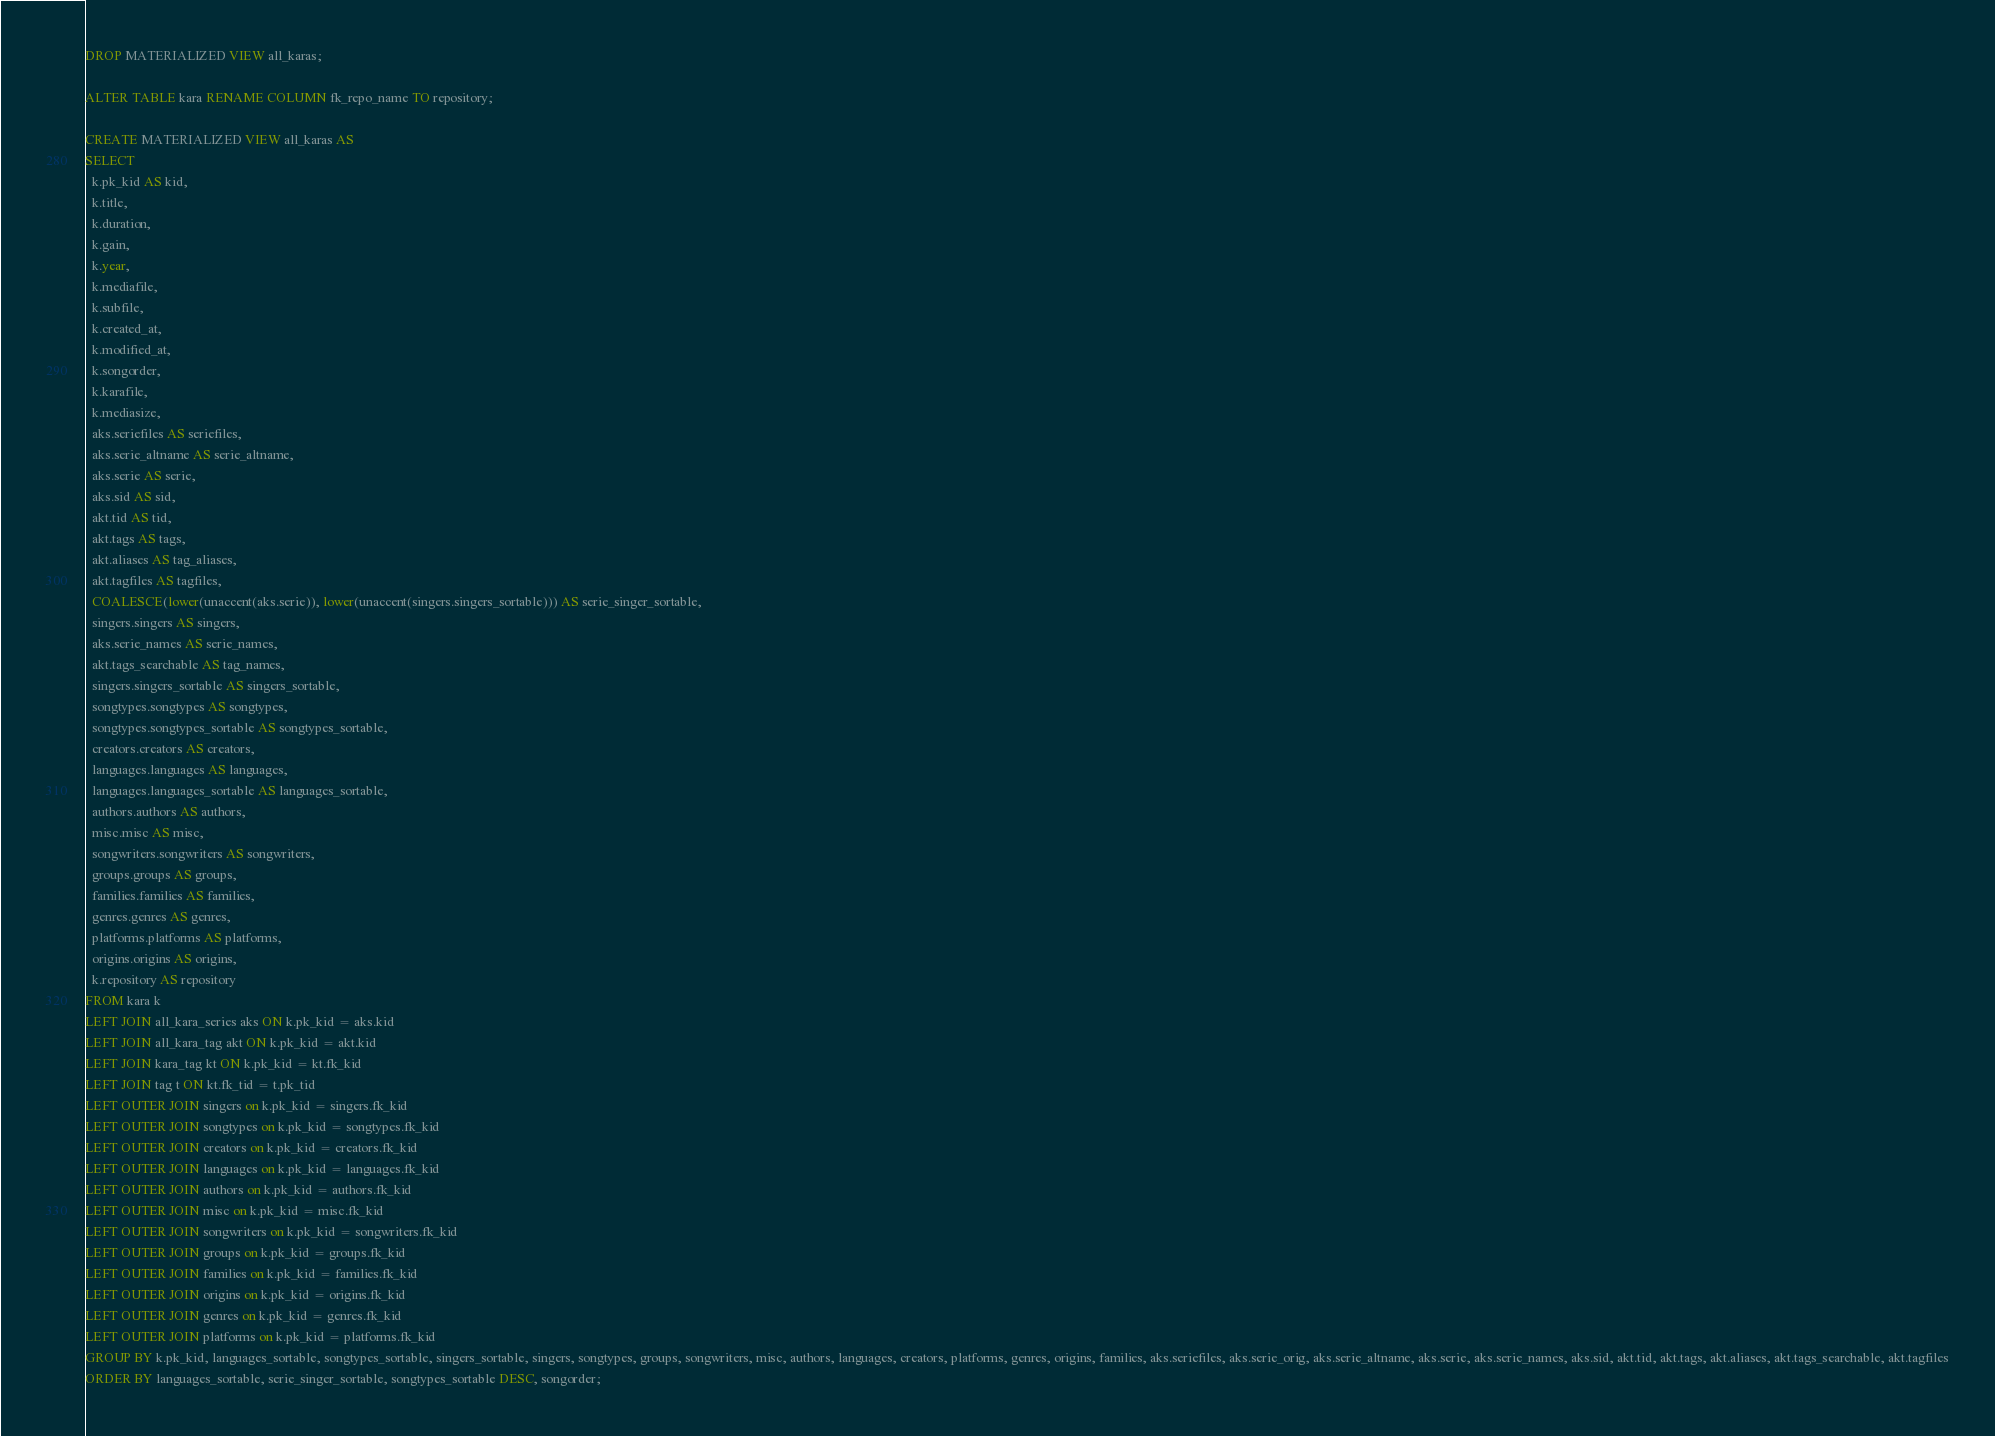Convert code to text. <code><loc_0><loc_0><loc_500><loc_500><_SQL_>
DROP MATERIALIZED VIEW all_karas;

ALTER TABLE kara RENAME COLUMN fk_repo_name TO repository;

CREATE MATERIALIZED VIEW all_karas AS
SELECT
  k.pk_kid AS kid,
  k.title,
  k.duration,
  k.gain,
  k.year,
  k.mediafile,
  k.subfile,
  k.created_at,
  k.modified_at,
  k.songorder,
  k.karafile,
  k.mediasize,
  aks.seriefiles AS seriefiles,
  aks.serie_altname AS serie_altname,
  aks.serie AS serie,
  aks.sid AS sid,
  akt.tid AS tid,
  akt.tags AS tags,
  akt.aliases AS tag_aliases,
  akt.tagfiles AS tagfiles,
  COALESCE(lower(unaccent(aks.serie)), lower(unaccent(singers.singers_sortable))) AS serie_singer_sortable,
  singers.singers AS singers,
  aks.serie_names AS serie_names,
  akt.tags_searchable AS tag_names,
  singers.singers_sortable AS singers_sortable,
  songtypes.songtypes AS songtypes,
  songtypes.songtypes_sortable AS songtypes_sortable,
  creators.creators AS creators,
  languages.languages AS languages,
  languages.languages_sortable AS languages_sortable,
  authors.authors AS authors,
  misc.misc AS misc,
  songwriters.songwriters AS songwriters,
  groups.groups AS groups,
  families.families AS families,
  genres.genres AS genres,
  platforms.platforms AS platforms,
  origins.origins AS origins,
  k.repository AS repository
FROM kara k
LEFT JOIN all_kara_series aks ON k.pk_kid = aks.kid
LEFT JOIN all_kara_tag akt ON k.pk_kid = akt.kid
LEFT JOIN kara_tag kt ON k.pk_kid = kt.fk_kid
LEFT JOIN tag t ON kt.fk_tid = t.pk_tid
LEFT OUTER JOIN singers on k.pk_kid = singers.fk_kid
LEFT OUTER JOIN songtypes on k.pk_kid = songtypes.fk_kid
LEFT OUTER JOIN creators on k.pk_kid = creators.fk_kid
LEFT OUTER JOIN languages on k.pk_kid = languages.fk_kid
LEFT OUTER JOIN authors on k.pk_kid = authors.fk_kid
LEFT OUTER JOIN misc on k.pk_kid = misc.fk_kid
LEFT OUTER JOIN songwriters on k.pk_kid = songwriters.fk_kid
LEFT OUTER JOIN groups on k.pk_kid = groups.fk_kid
LEFT OUTER JOIN families on k.pk_kid = families.fk_kid
LEFT OUTER JOIN origins on k.pk_kid = origins.fk_kid
LEFT OUTER JOIN genres on k.pk_kid = genres.fk_kid
LEFT OUTER JOIN platforms on k.pk_kid = platforms.fk_kid
GROUP BY k.pk_kid, languages_sortable, songtypes_sortable, singers_sortable, singers, songtypes, groups, songwriters, misc, authors, languages, creators, platforms, genres, origins, families, aks.seriefiles, aks.serie_orig, aks.serie_altname, aks.serie, aks.serie_names, aks.sid, akt.tid, akt.tags, akt.aliases, akt.tags_searchable, akt.tagfiles
ORDER BY languages_sortable, serie_singer_sortable, songtypes_sortable DESC, songorder;
</code> 